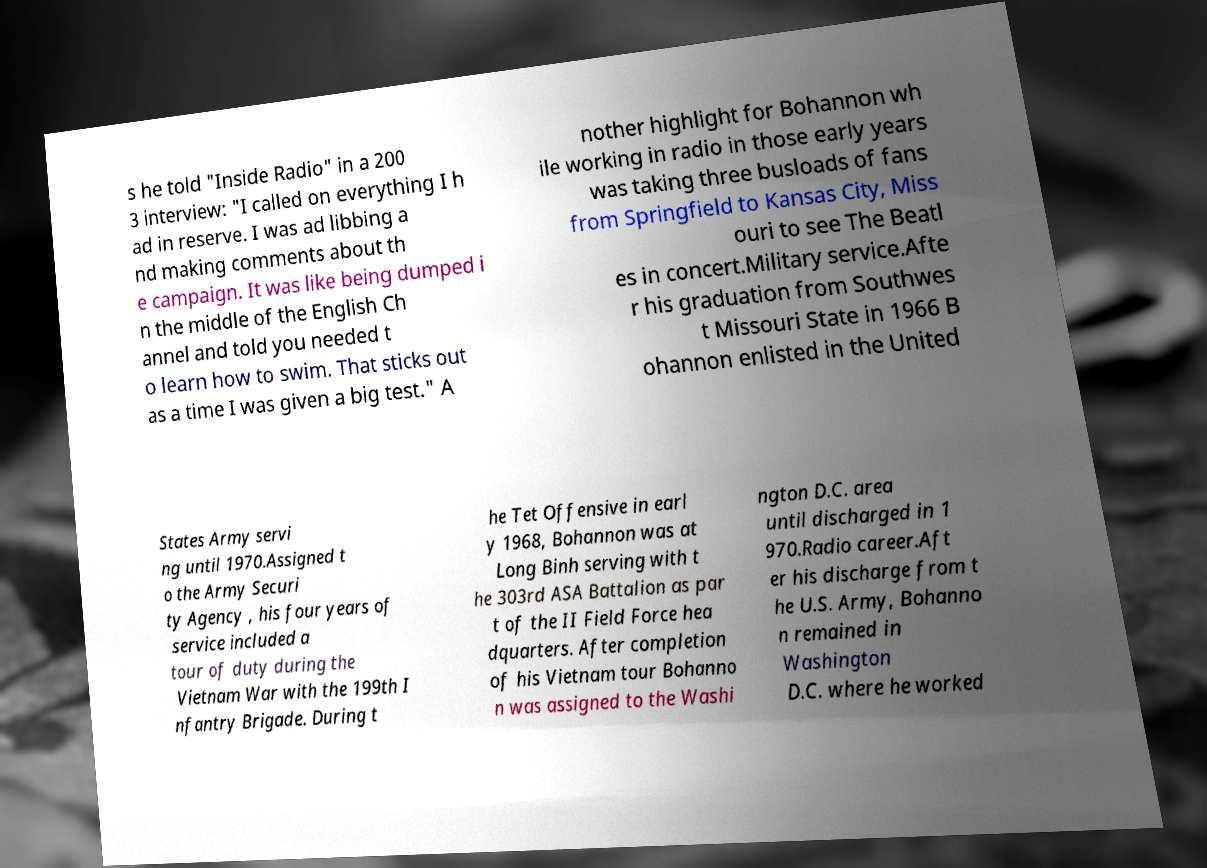Please identify and transcribe the text found in this image. s he told "Inside Radio" in a 200 3 interview: "I called on everything I h ad in reserve. I was ad libbing a nd making comments about th e campaign. It was like being dumped i n the middle of the English Ch annel and told you needed t o learn how to swim. That sticks out as a time I was given a big test." A nother highlight for Bohannon wh ile working in radio in those early years was taking three busloads of fans from Springfield to Kansas City, Miss ouri to see The Beatl es in concert.Military service.Afte r his graduation from Southwes t Missouri State in 1966 B ohannon enlisted in the United States Army servi ng until 1970.Assigned t o the Army Securi ty Agency , his four years of service included a tour of duty during the Vietnam War with the 199th I nfantry Brigade. During t he Tet Offensive in earl y 1968, Bohannon was at Long Binh serving with t he 303rd ASA Battalion as par t of the II Field Force hea dquarters. After completion of his Vietnam tour Bohanno n was assigned to the Washi ngton D.C. area until discharged in 1 970.Radio career.Aft er his discharge from t he U.S. Army, Bohanno n remained in Washington D.C. where he worked 